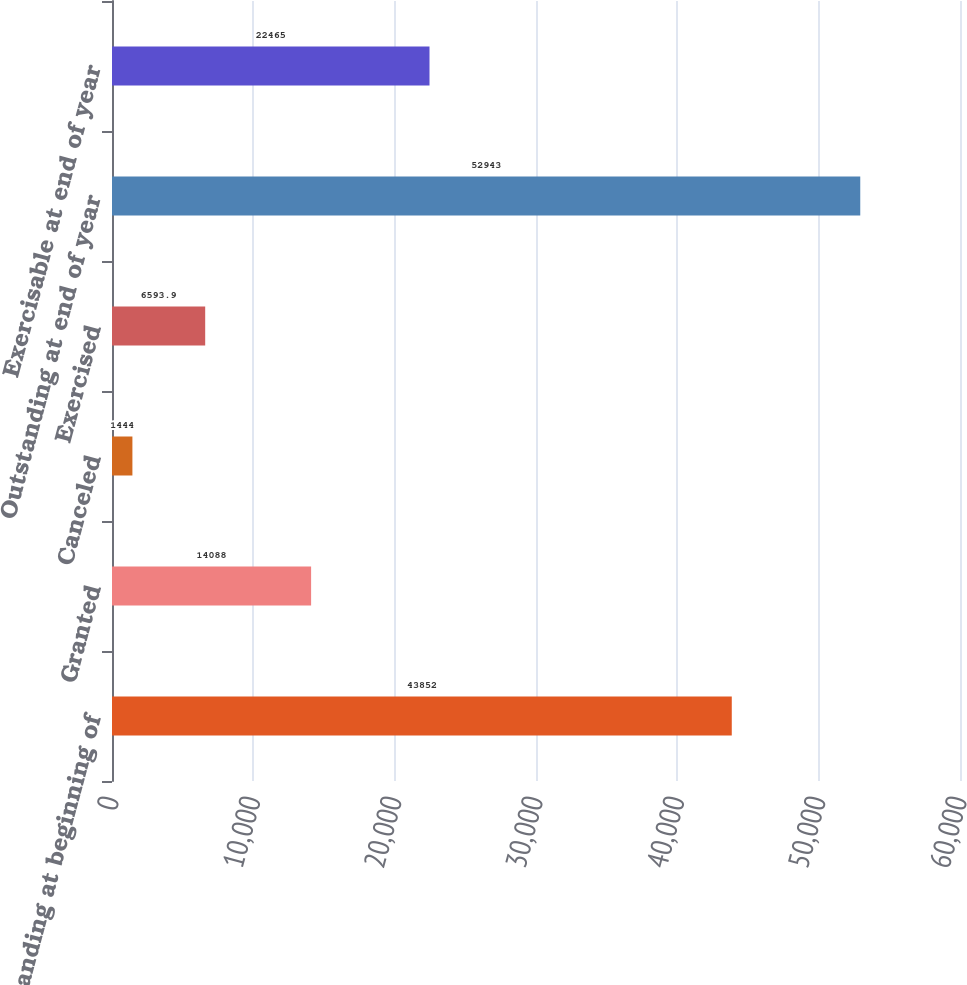<chart> <loc_0><loc_0><loc_500><loc_500><bar_chart><fcel>Outstanding at beginning of<fcel>Granted<fcel>Canceled<fcel>Exercised<fcel>Outstanding at end of year<fcel>Exercisable at end of year<nl><fcel>43852<fcel>14088<fcel>1444<fcel>6593.9<fcel>52943<fcel>22465<nl></chart> 